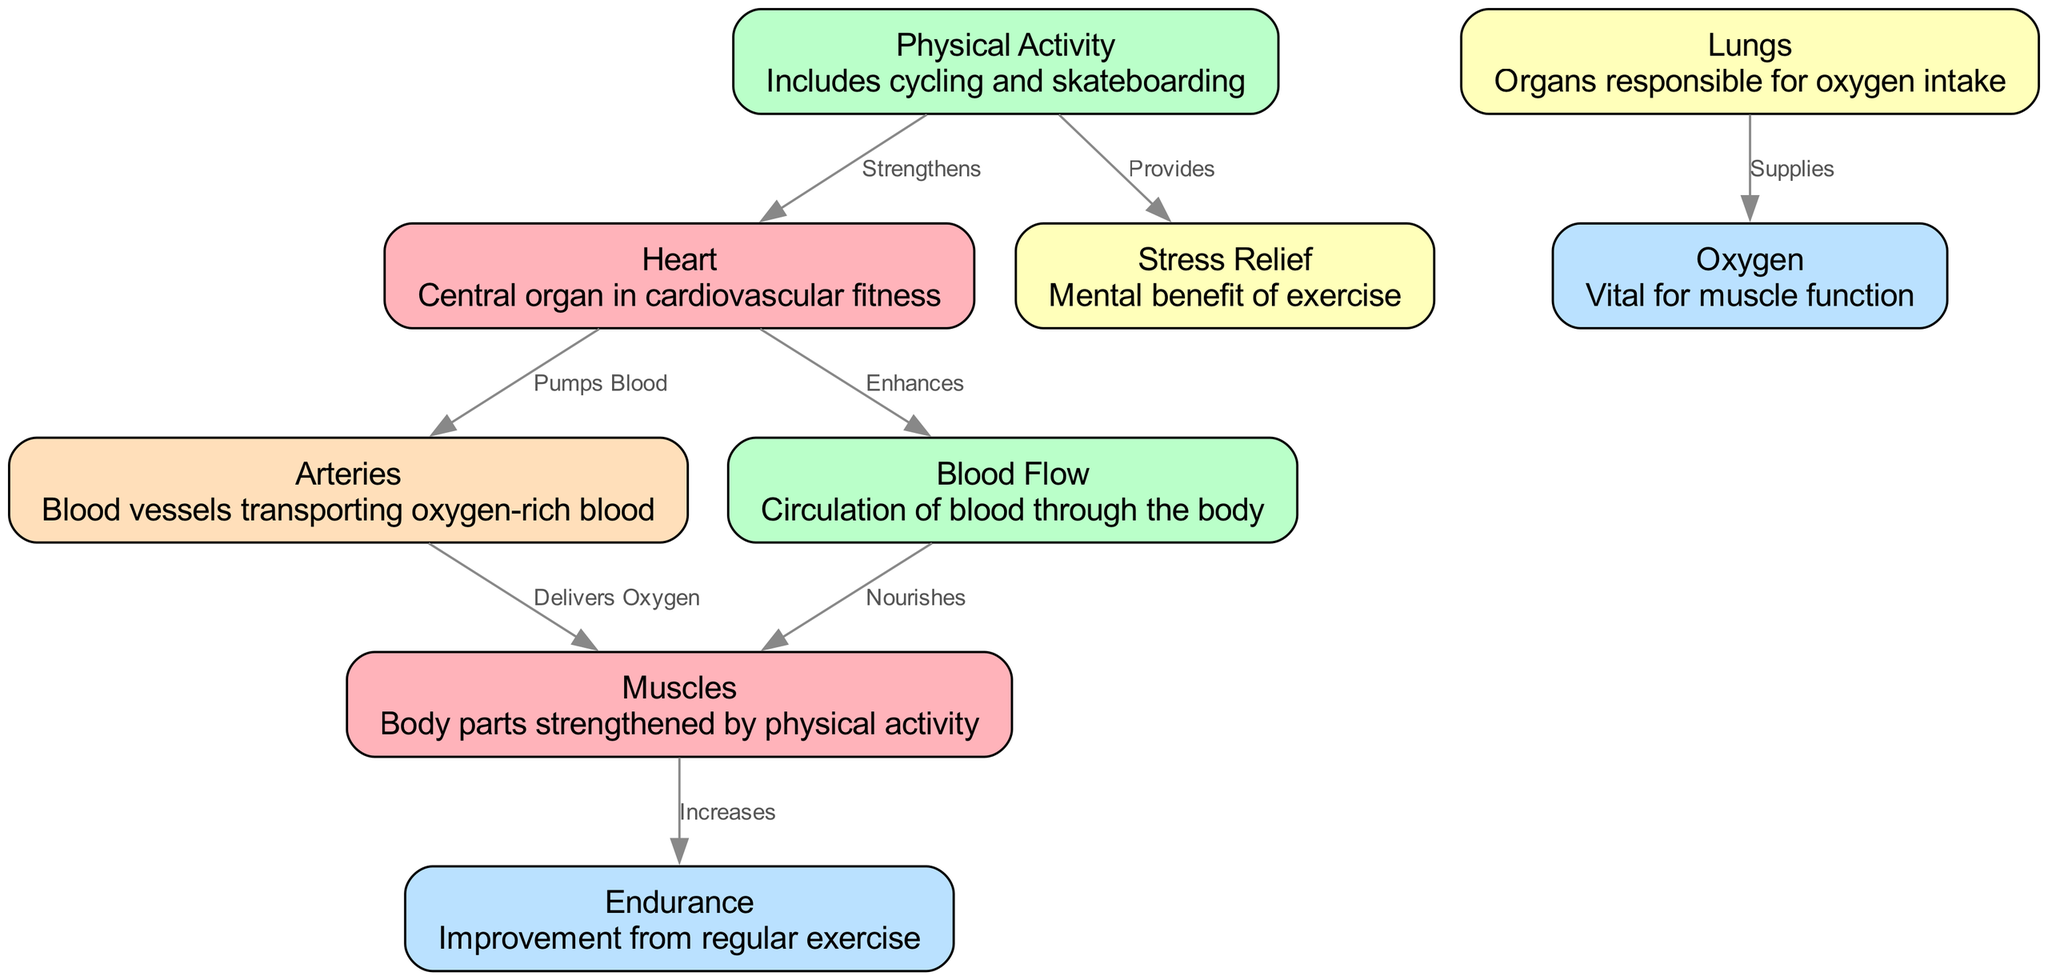What is the central organ in cardiovascular fitness? The diagram identifies the "Heart" as the central organ. It is listed as a node in the diagram with a description explicitly stating its importance.
Answer: Heart How many nodes are in the diagram? By counting the nodes presented in the data, we can find there are 8 distinct nodes describing different aspects of cardiovascular fitness.
Answer: 8 What relationship does exercise have with the heart? The diagram shows an edge labeled "Strengthens" from the node "Physical Activity" to the node "Heart," indicating a direct relationship where exercise strengthens the heart.
Answer: Strengthens Which organ is responsible for oxygen intake? The diagram specifies "Lungs" as the organ responsible for oxygen intake. This is clearly indicated as a node with a corresponding description.
Answer: Lungs How does the heart affect blood flow? The relationship is displayed in the diagram with the edge labeled "Enhances" from the heart to the blood flow node, showing that the heart enhances blood flow throughout the body.
Answer: Enhances What is delivered to the muscles via arteries? The diagram indicates that arteries carry oxygen-rich blood to the muscles, as denoted by the edge labeled "Delivers Oxygen."
Answer: Oxygen How does exercise provide mental benefits? The diagram illustrates that exercise relates to "Stress Relief" through the labeled edge "Provides" to the stress relief node, indicating it offers mental health benefits.
Answer: Provides What improves as a result of regular exercise? The diagram states that endurance is increased due to the activity of muscles involved in regular exercise, as shown by the edge labeled "Increases."
Answer: Endurance 